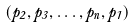<formula> <loc_0><loc_0><loc_500><loc_500>( p _ { 2 } , p _ { 3 } , \dots , p _ { n } , p _ { 1 } )</formula> 